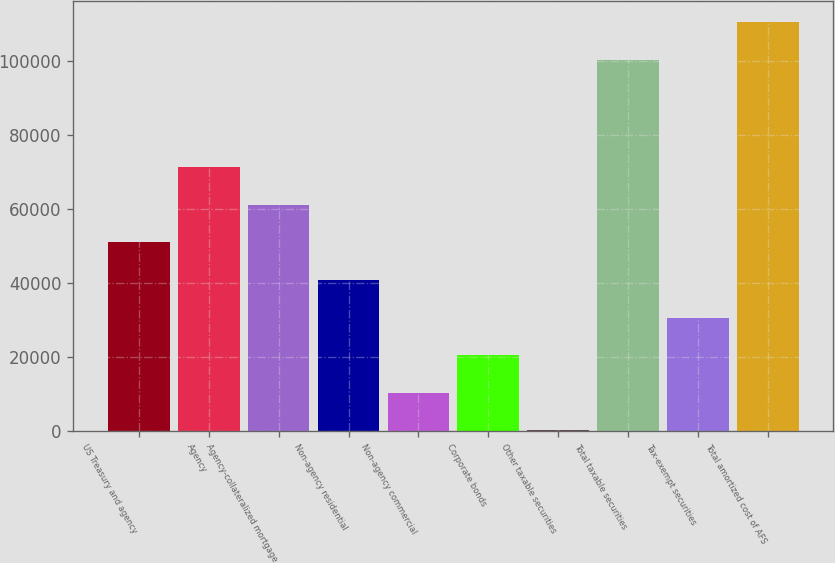<chart> <loc_0><loc_0><loc_500><loc_500><bar_chart><fcel>US Treasury and agency<fcel>Agency<fcel>Agency-collateralized mortgage<fcel>Non-agency residential<fcel>Non-agency commercial<fcel>Corporate bonds<fcel>Other taxable securities<fcel>Total taxable securities<fcel>Tax-exempt securities<fcel>Total amortized cost of AFS<nl><fcel>50958<fcel>71294<fcel>61126<fcel>40790<fcel>10286<fcel>20454<fcel>118<fcel>100390<fcel>30622<fcel>110558<nl></chart> 